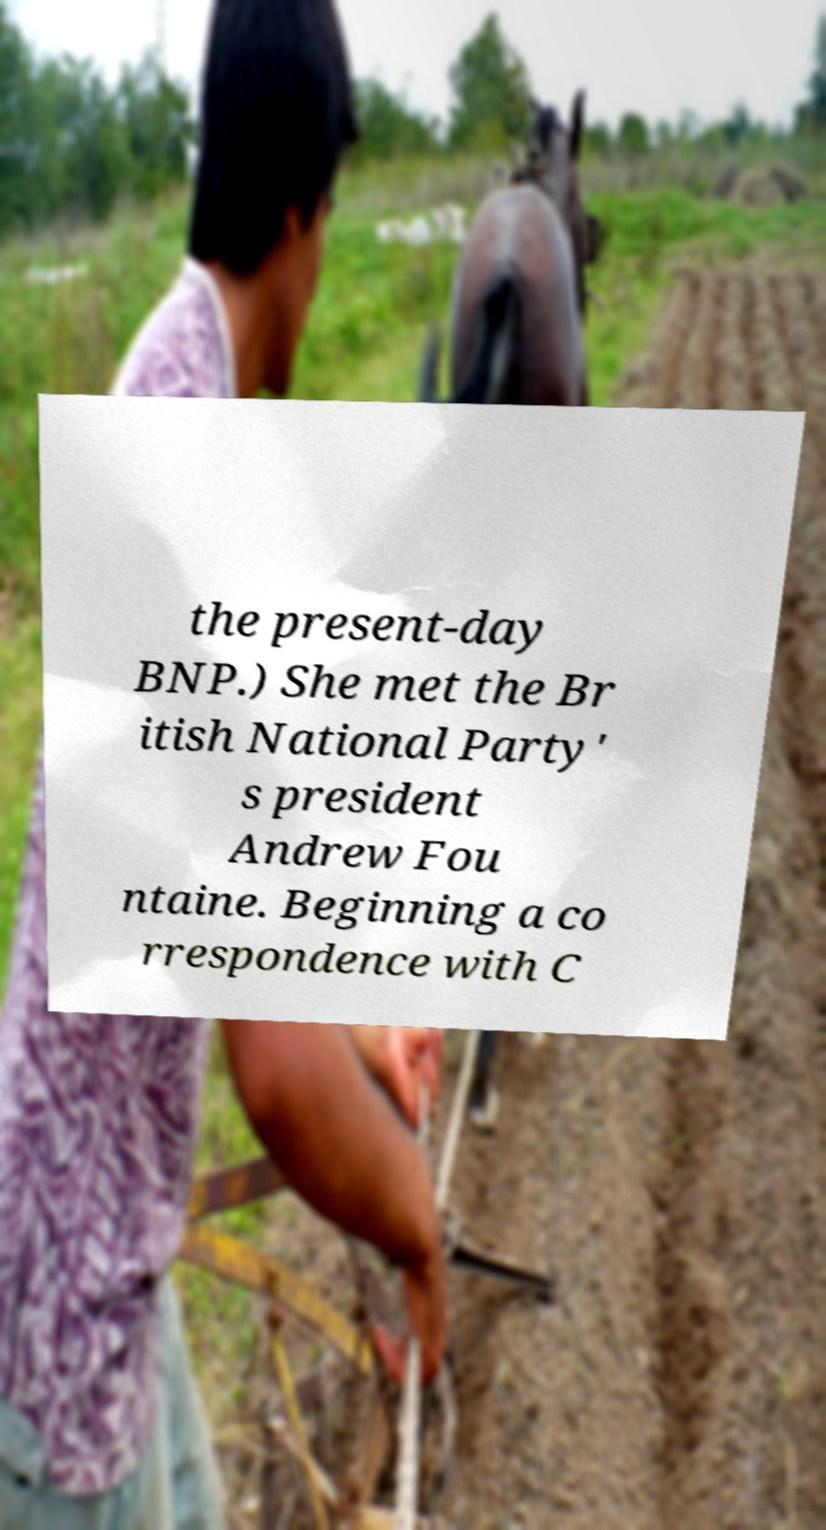Could you extract and type out the text from this image? the present-day BNP.) She met the Br itish National Party' s president Andrew Fou ntaine. Beginning a co rrespondence with C 